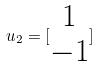<formula> <loc_0><loc_0><loc_500><loc_500>u _ { 2 } = [ \begin{matrix} 1 \\ - 1 \end{matrix} ]</formula> 